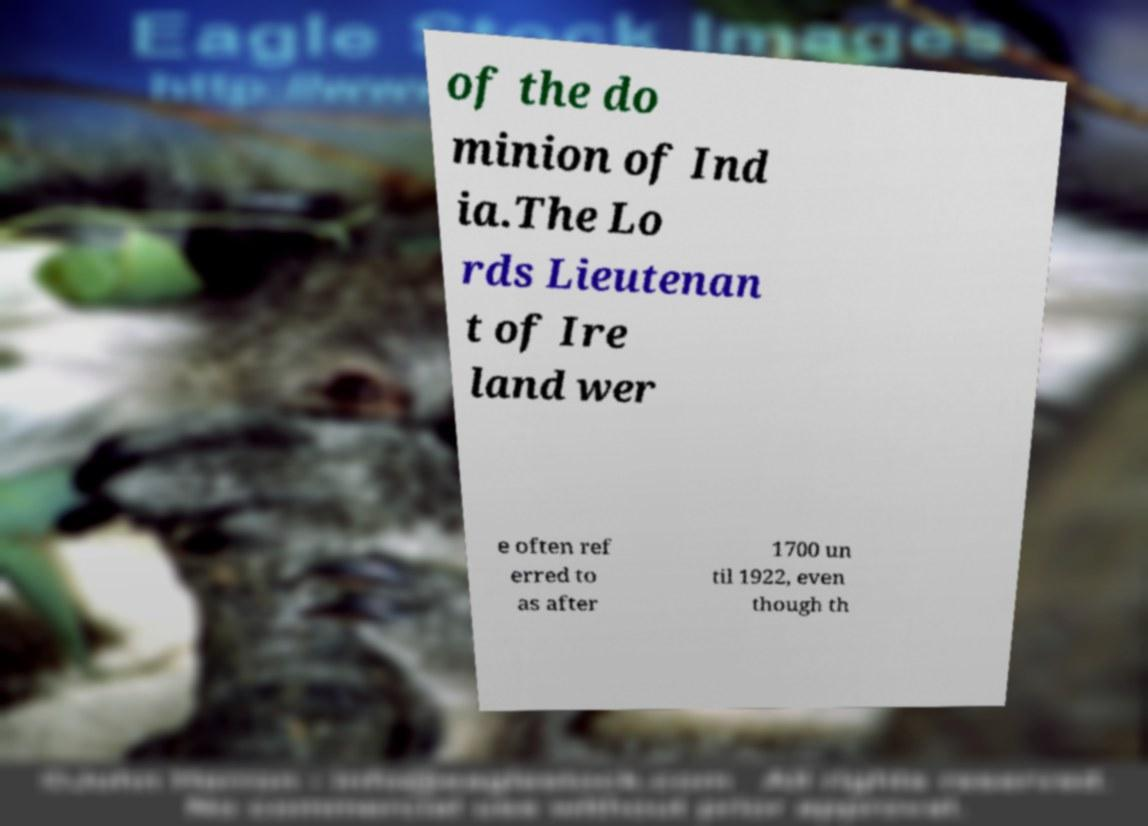For documentation purposes, I need the text within this image transcribed. Could you provide that? of the do minion of Ind ia.The Lo rds Lieutenan t of Ire land wer e often ref erred to as after 1700 un til 1922, even though th 